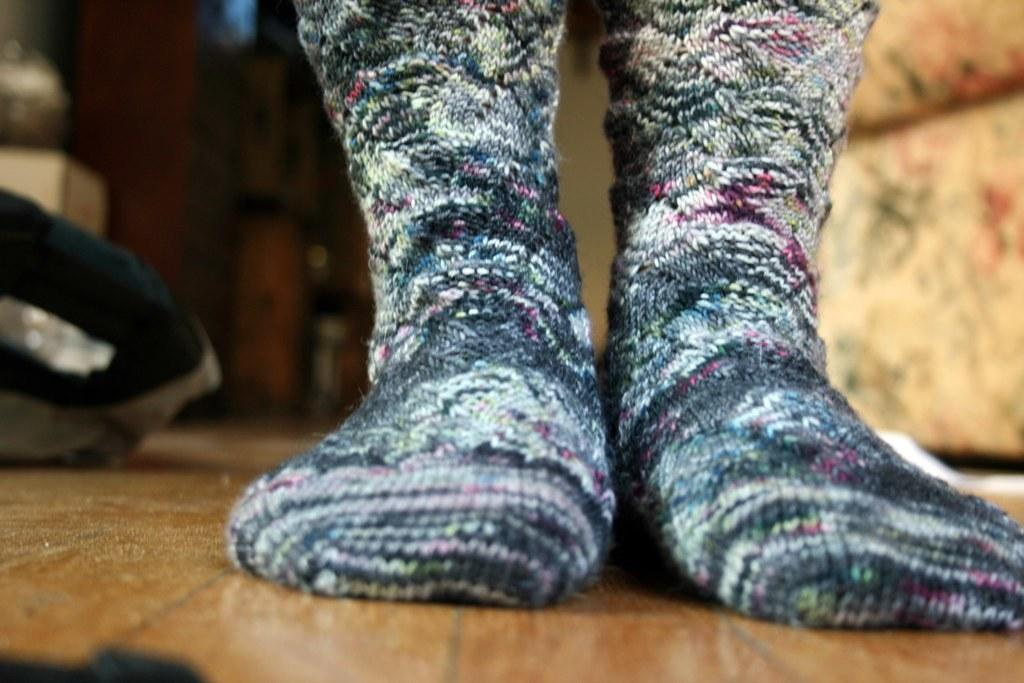What objects are present in the image? There are two socks in the image. What colors are the socks? One sock is black, and the other is white. Where are the socks located? The socks are on the floor. What type of band is playing on the canvas in the image? There is no band or canvas present in the image; it only features two socks on the floor. 